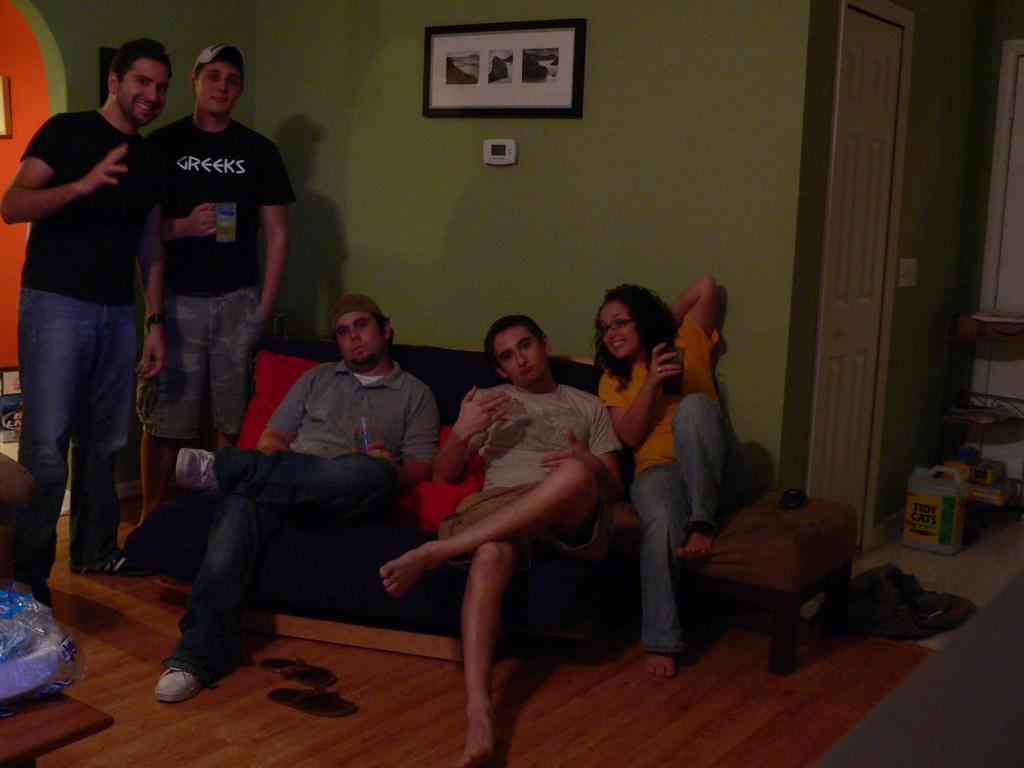How would you summarize this image in a sentence or two? As we can see in the image there is a wall, photo frame, door, few people here and there and sofa. On the right side there is a box. 